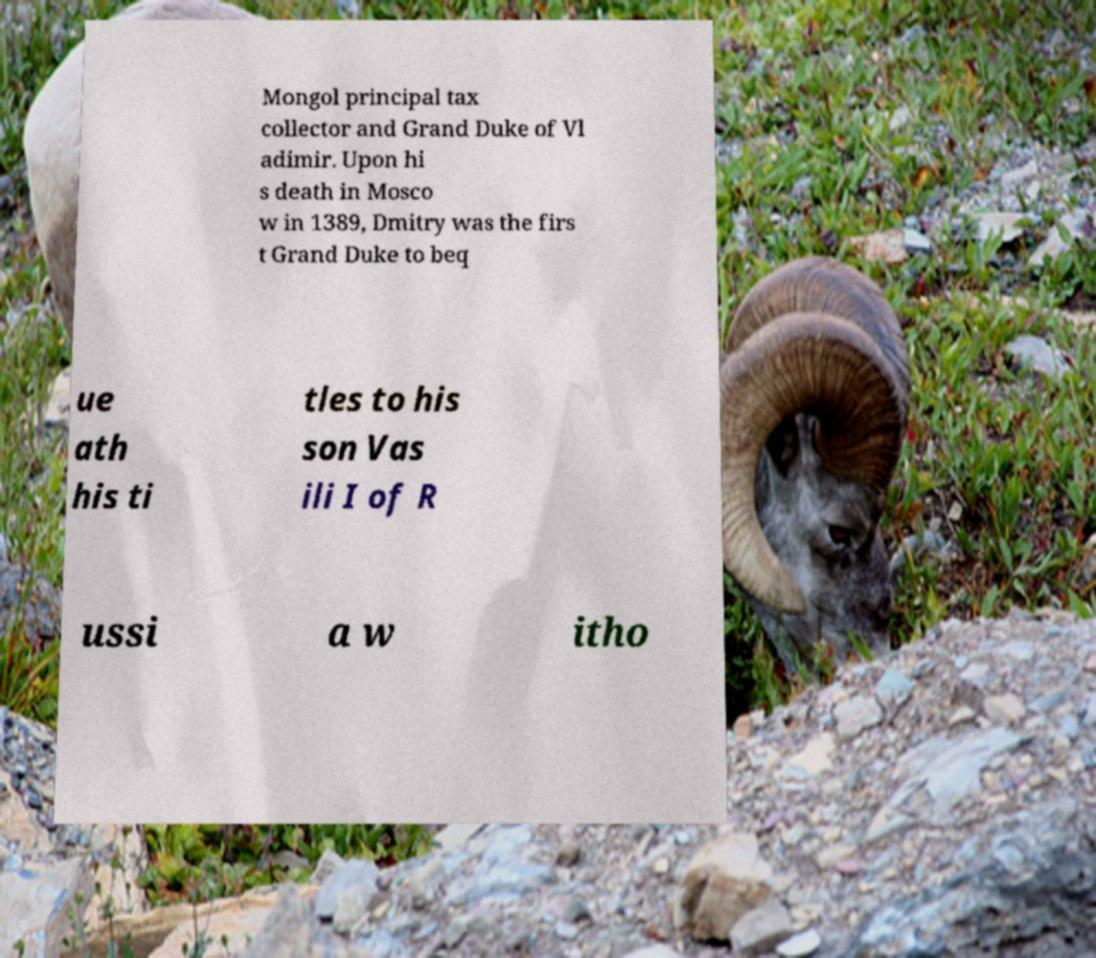Can you accurately transcribe the text from the provided image for me? Mongol principal tax collector and Grand Duke of Vl adimir. Upon hi s death in Mosco w in 1389, Dmitry was the firs t Grand Duke to beq ue ath his ti tles to his son Vas ili I of R ussi a w itho 